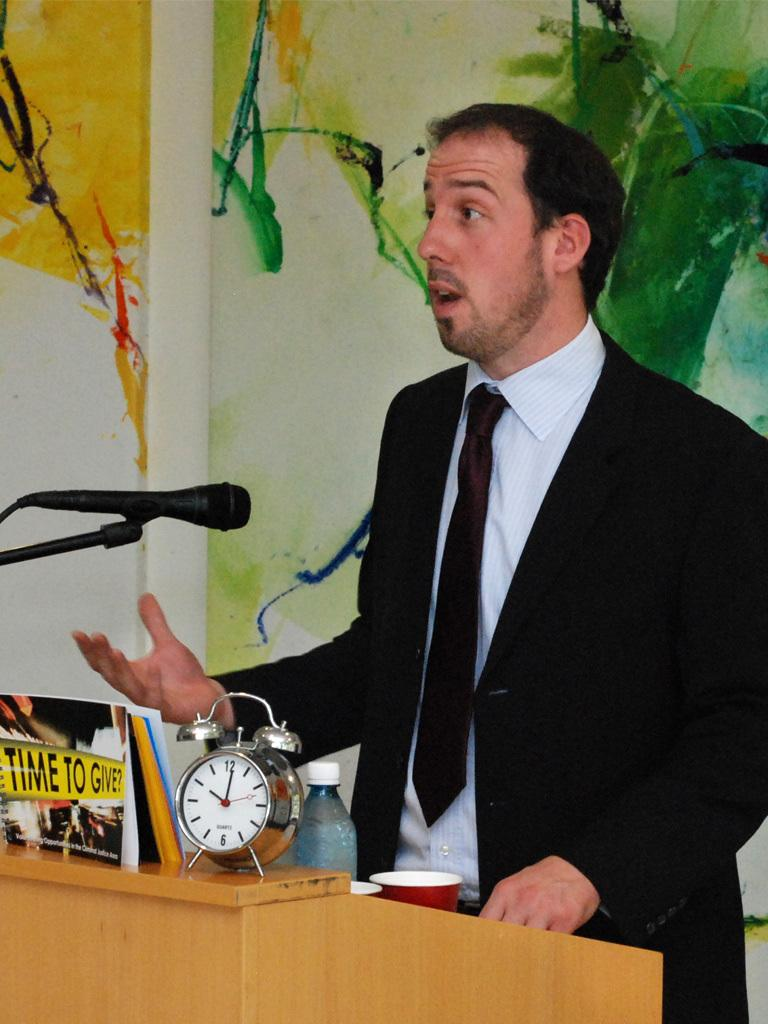<image>
Render a clear and concise summary of the photo. A speaker at a podium with a book titled Time to Give. 